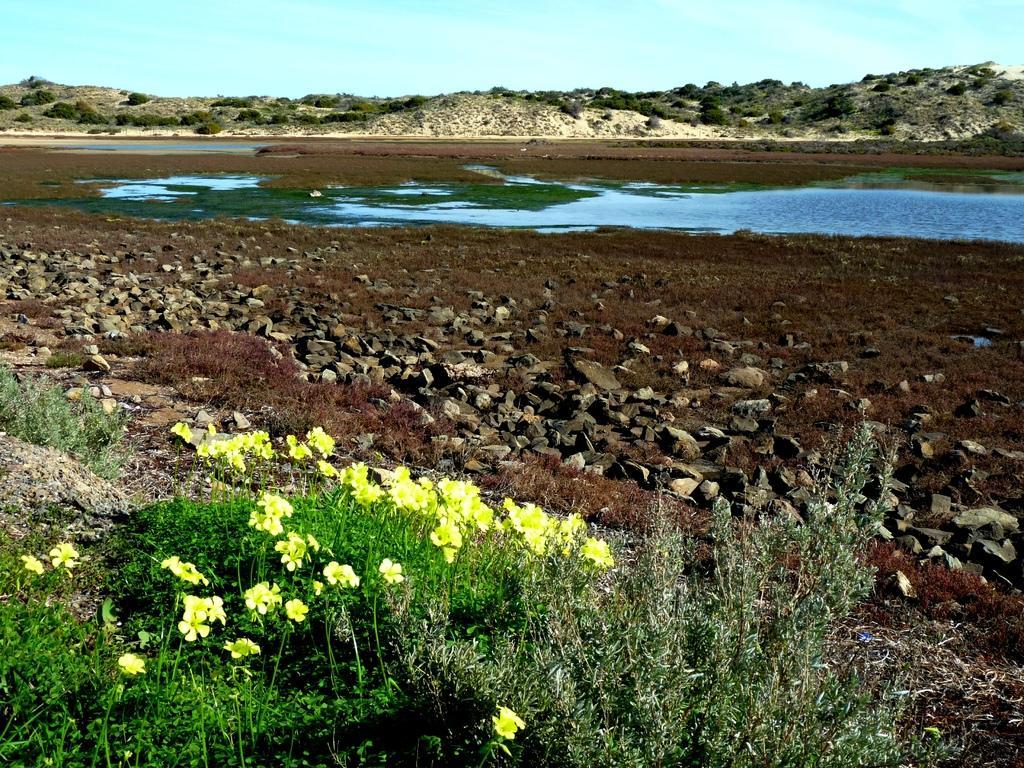Describe this image in one or two sentences. In front of the image there are plants and flowers. There are rocks and grass on the surface. There is water. In the background of the image there are trees. At the top of the image there is sky. 